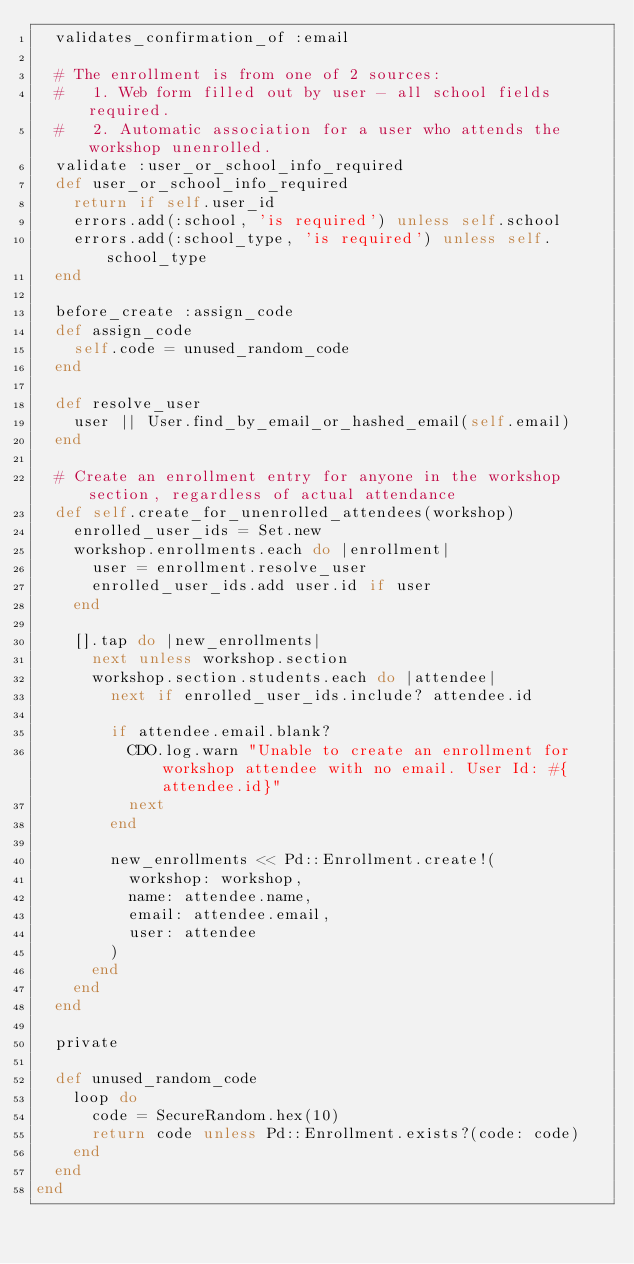<code> <loc_0><loc_0><loc_500><loc_500><_Ruby_>  validates_confirmation_of :email

  # The enrollment is from one of 2 sources:
  #   1. Web form filled out by user - all school fields required.
  #   2. Automatic association for a user who attends the workshop unenrolled.
  validate :user_or_school_info_required
  def user_or_school_info_required
    return if self.user_id
    errors.add(:school, 'is required') unless self.school
    errors.add(:school_type, 'is required') unless self.school_type
  end

  before_create :assign_code
  def assign_code
    self.code = unused_random_code
  end

  def resolve_user
    user || User.find_by_email_or_hashed_email(self.email)
  end

  # Create an enrollment entry for anyone in the workshop section, regardless of actual attendance
  def self.create_for_unenrolled_attendees(workshop)
    enrolled_user_ids = Set.new
    workshop.enrollments.each do |enrollment|
      user = enrollment.resolve_user
      enrolled_user_ids.add user.id if user
    end

    [].tap do |new_enrollments|
      next unless workshop.section
      workshop.section.students.each do |attendee|
        next if enrolled_user_ids.include? attendee.id

        if attendee.email.blank?
          CDO.log.warn "Unable to create an enrollment for workshop attendee with no email. User Id: #{attendee.id}"
          next
        end

        new_enrollments << Pd::Enrollment.create!(
          workshop: workshop,
          name: attendee.name,
          email: attendee.email,
          user: attendee
        )
      end
    end
  end

  private

  def unused_random_code
    loop do
      code = SecureRandom.hex(10)
      return code unless Pd::Enrollment.exists?(code: code)
    end
  end
end
</code> 